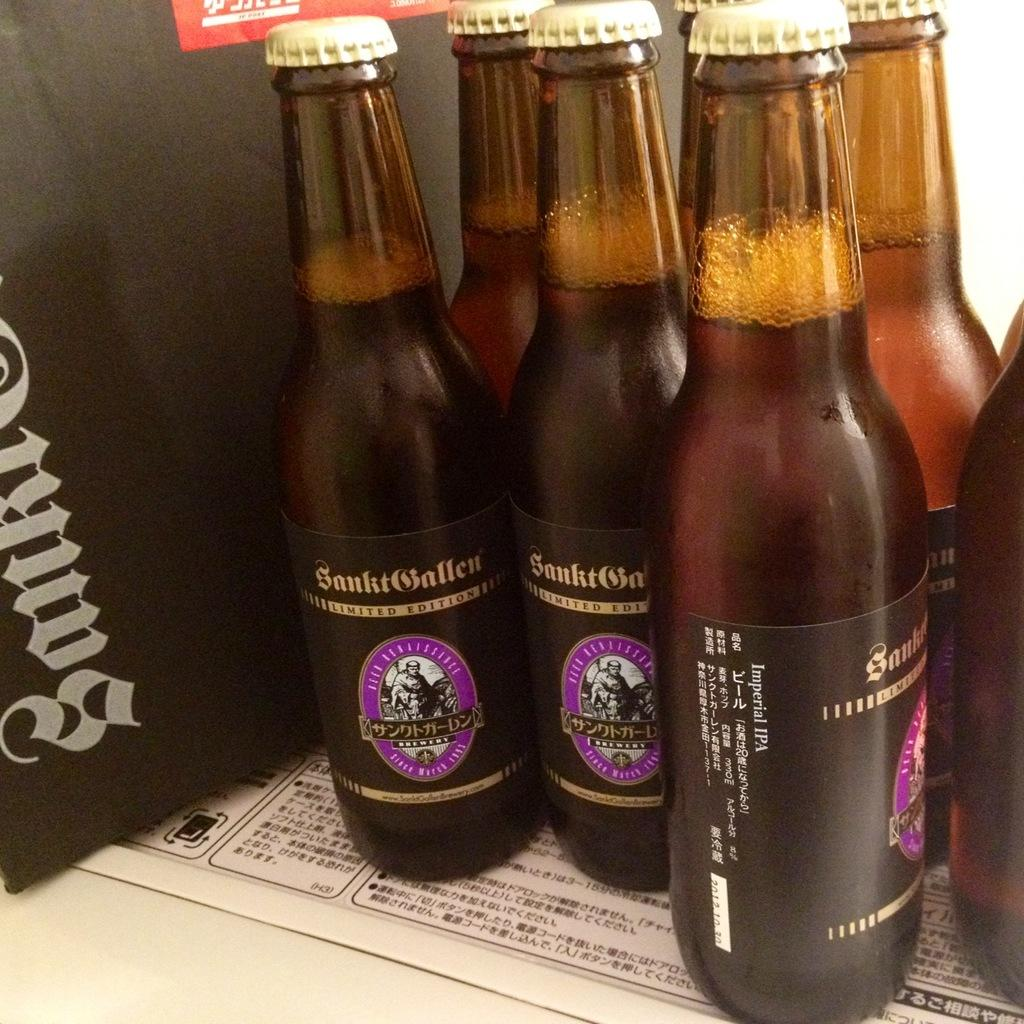<image>
Give a short and clear explanation of the subsequent image. bottles of snktballen limited edition standing next to each other 